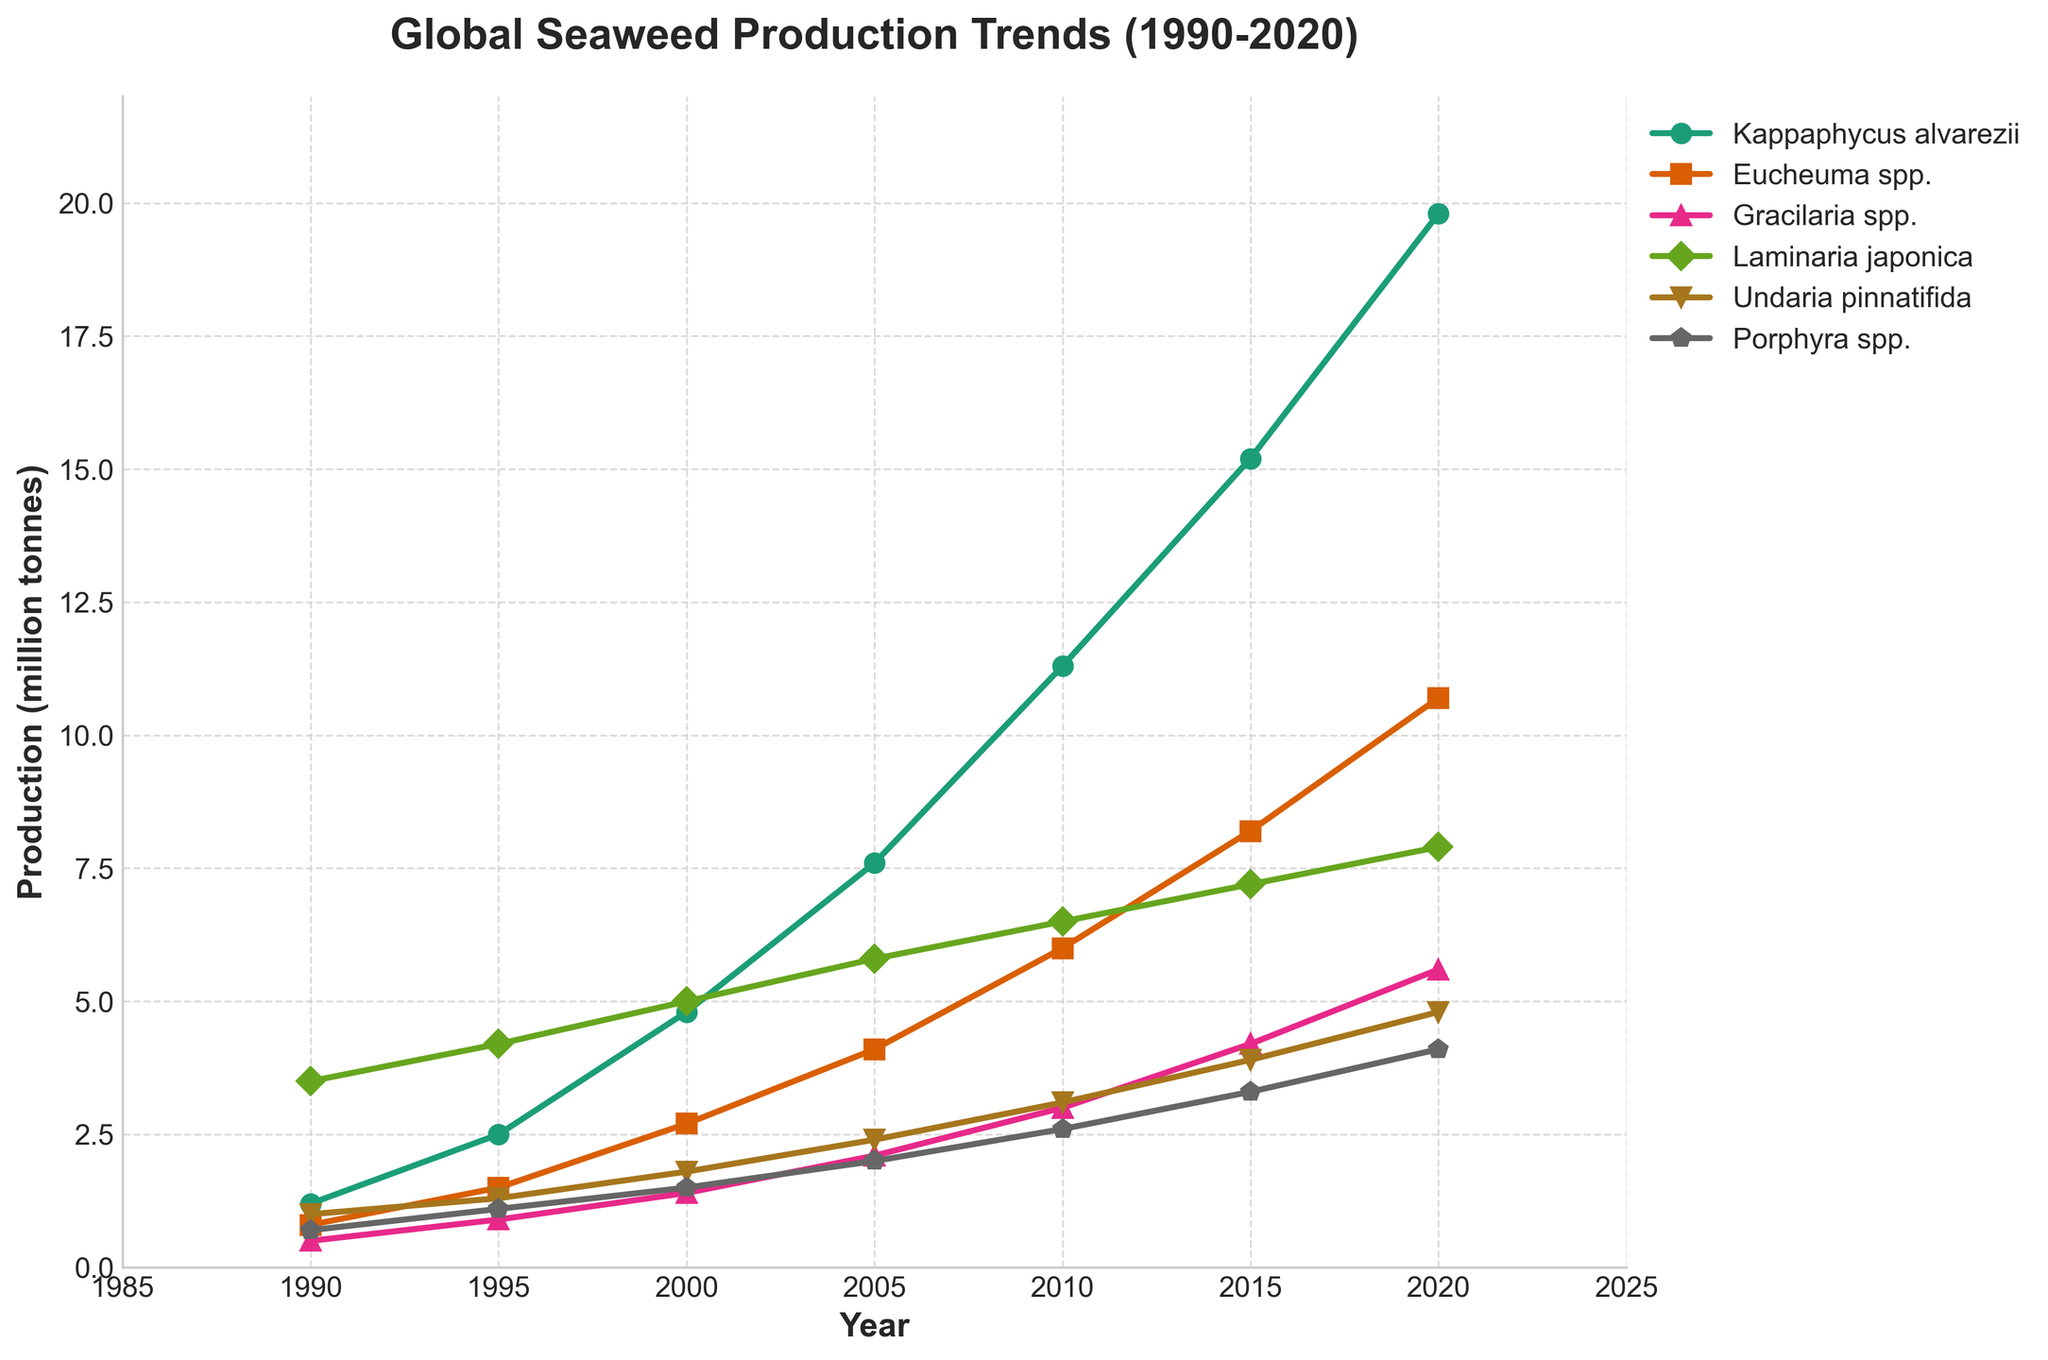When did Kappaphycus alvarezii production surpass 10 million tonnes? The line for Kappaphycus alvarezii shows that it surpassed 10 million tonnes between 2005 and 2010, specifically in 2010.
Answer: 2010 Which species had the lowest production in 2020? By examining the lines in the chart at the 2020 mark, Porphyra spp. has the lowest production figure.
Answer: Porphyra spp How much did the production of Eucheuma spp. increase from 1990 to 2020? To find this, subtract the 1990 production value from the 2020 production value for Eucheuma spp. (10.7 - 0.8).
Answer: 9.9 million tonnes Which two species had the smallest difference in production in 1990? Compare the production values for all species in 1990 and find the smallest difference between two species. Here, it is between Eucheuma spp. and Undaria pinnatifida (0.8 and 1.0).
Answer: Eucheuma spp. and Undaria pinnatifida What is the average production of Gracilaria spp. from 2000 to 2020? Sum the production values of Gracilaria spp. for the years 2000, 2005, 2010, 2015, and 2020, and divide by the number of years. (1.4 + 2.1 + 3 + 4.2 + 5.6) / 5.
Answer: 3.26 million tonnes Which species had the most consistent growth trend from 1990 to 2020? Evaluate the smoothness and linearity of the lines for each species; Kappaphycus alvarezii shows the most consistent and steady growth.
Answer: Kappaphycus alvarezii In which year did Laminaria japonica production peak, and what was the amount? Find the highest point on the line representing Laminaria japonica; this peak occurs in 2020 at 7.9 million tonnes.
Answer: 2020, 7.9 million tonnes Which species showed the most significant growth from 1990 to 2020? Find the species with the largest increase between 1990 and 2020. Kappaphycus alvarezii had an increase from 1.2 to 19.8, which is the most significant.
Answer: Kappaphycus alvarezii How many species had a production value greater than 5 million tonnes in 2015? Count the lines above the 5 million tonnes grid line in 2015: Kappaphycus alvarezii, Eucheuma spp., Gracilaria spp., and Laminaria japonica.
Answer: 4 species 